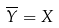<formula> <loc_0><loc_0><loc_500><loc_500>\overline { Y } = X</formula> 